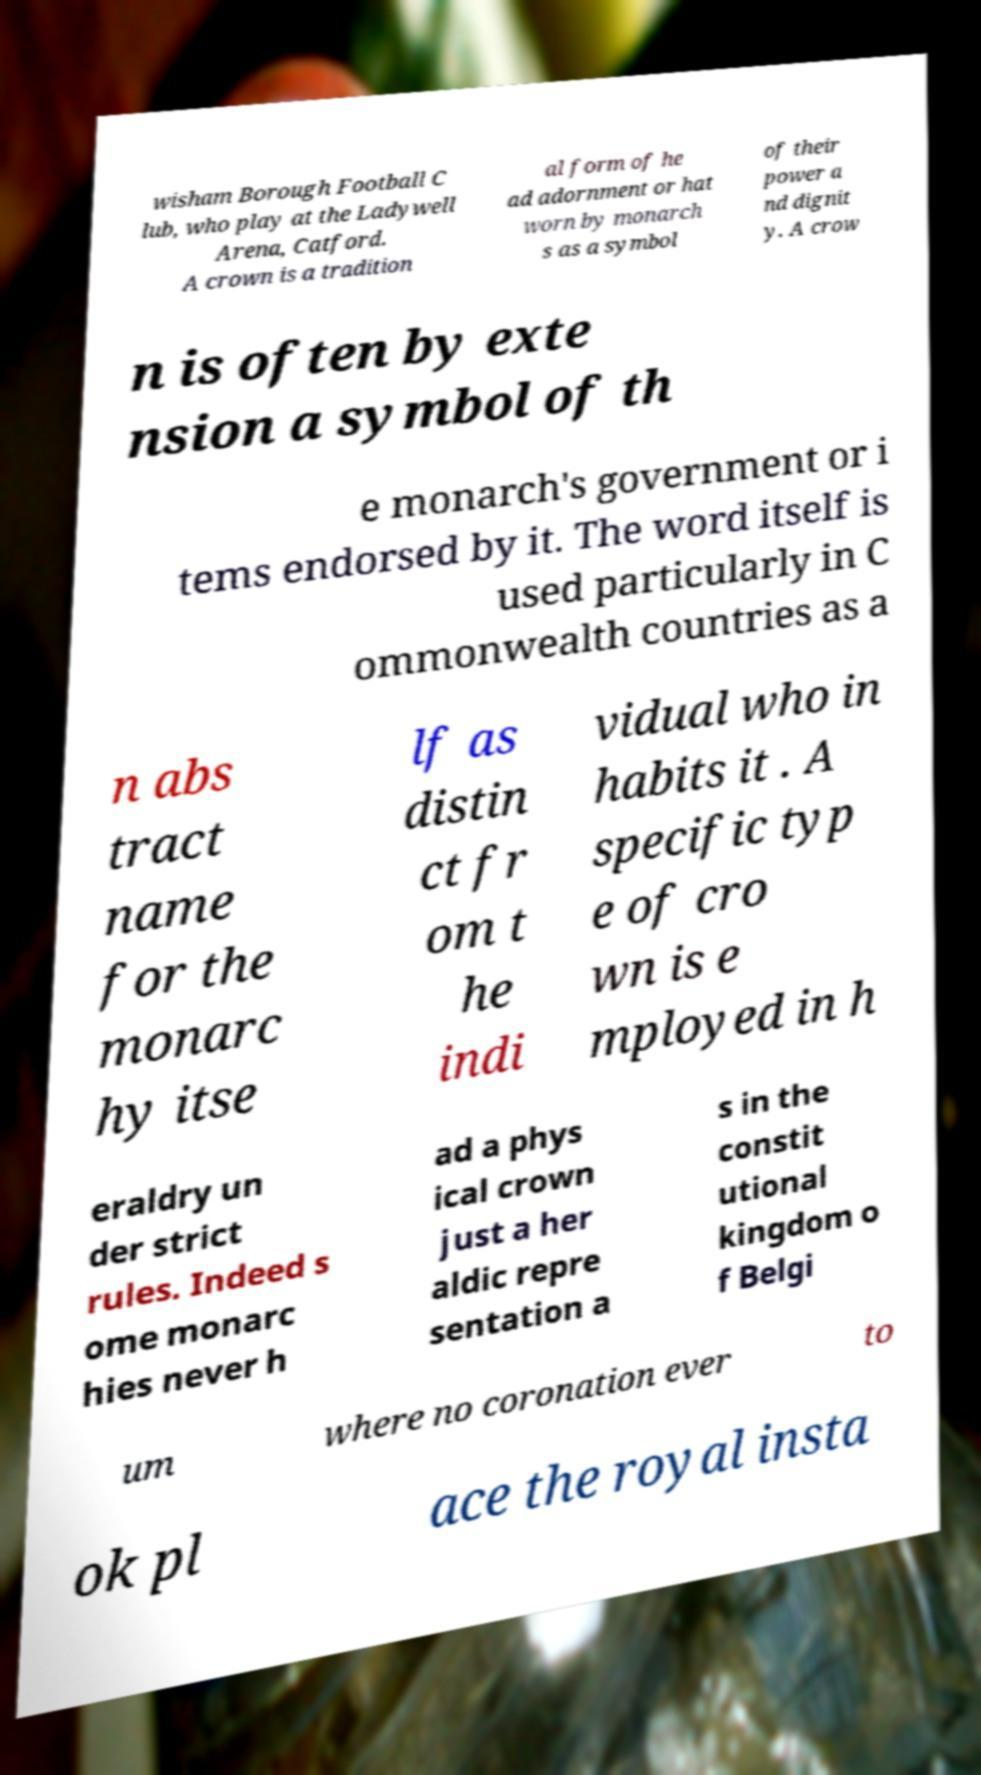There's text embedded in this image that I need extracted. Can you transcribe it verbatim? wisham Borough Football C lub, who play at the Ladywell Arena, Catford. A crown is a tradition al form of he ad adornment or hat worn by monarch s as a symbol of their power a nd dignit y. A crow n is often by exte nsion a symbol of th e monarch's government or i tems endorsed by it. The word itself is used particularly in C ommonwealth countries as a n abs tract name for the monarc hy itse lf as distin ct fr om t he indi vidual who in habits it . A specific typ e of cro wn is e mployed in h eraldry un der strict rules. Indeed s ome monarc hies never h ad a phys ical crown just a her aldic repre sentation a s in the constit utional kingdom o f Belgi um where no coronation ever to ok pl ace the royal insta 